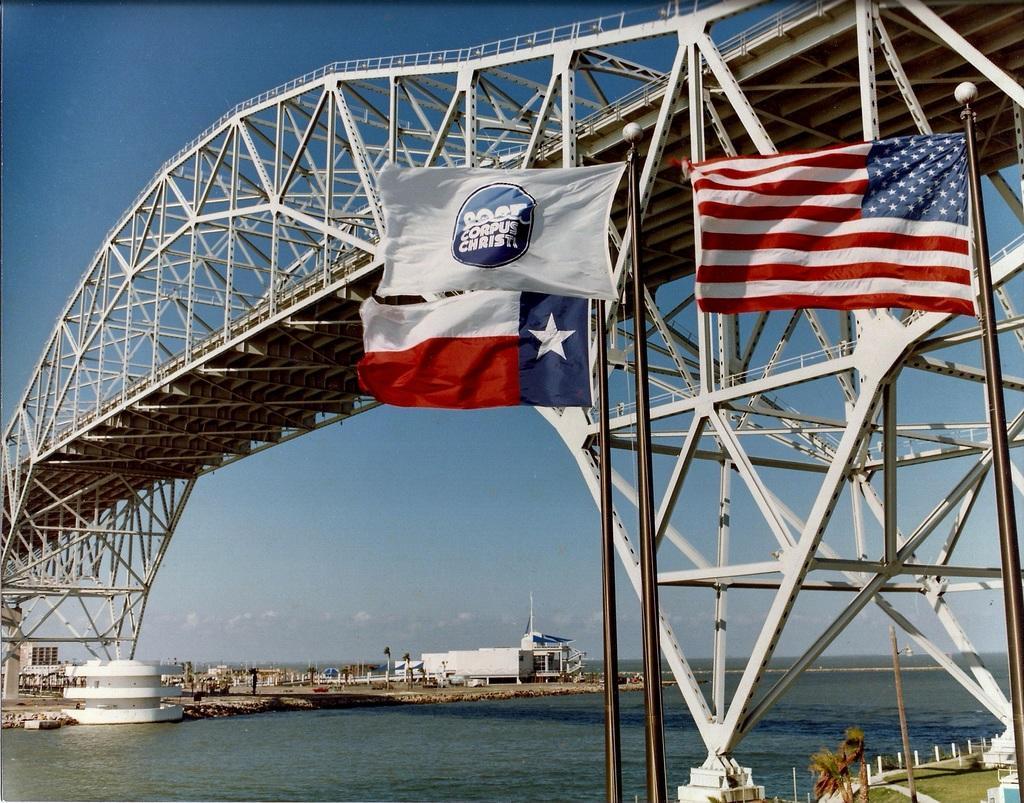Describe this image in one or two sentences. In this image I can see a bridge. Under the bridge there is a sea. On the right side there are few flags attached to the poles. In the bottom right, I can see the grass and trees on the ground. In the background there is a building, few trees and poles on the ground. At the top of the image I can see the sky in blue color. 